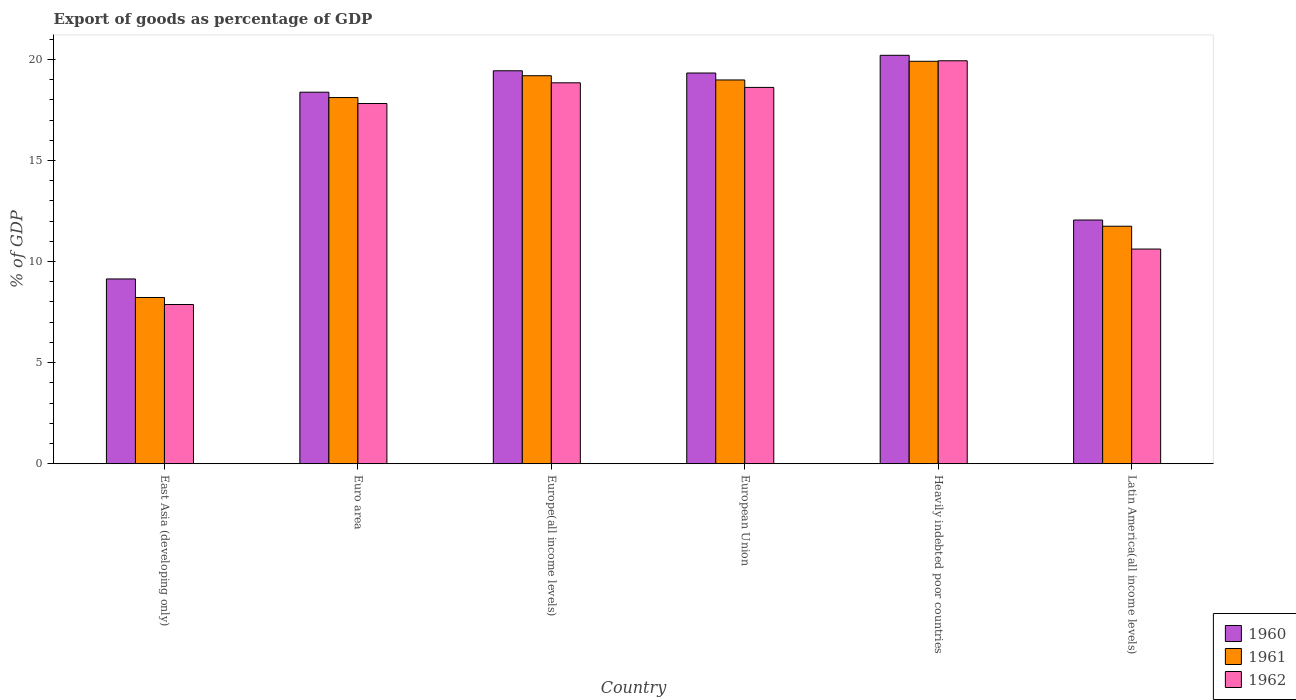How many groups of bars are there?
Give a very brief answer. 6. Are the number of bars on each tick of the X-axis equal?
Make the answer very short. Yes. How many bars are there on the 4th tick from the right?
Offer a terse response. 3. What is the label of the 2nd group of bars from the left?
Your answer should be compact. Euro area. What is the export of goods as percentage of GDP in 1961 in East Asia (developing only)?
Give a very brief answer. 8.22. Across all countries, what is the maximum export of goods as percentage of GDP in 1961?
Keep it short and to the point. 19.9. Across all countries, what is the minimum export of goods as percentage of GDP in 1962?
Give a very brief answer. 7.88. In which country was the export of goods as percentage of GDP in 1960 maximum?
Make the answer very short. Heavily indebted poor countries. In which country was the export of goods as percentage of GDP in 1961 minimum?
Make the answer very short. East Asia (developing only). What is the total export of goods as percentage of GDP in 1962 in the graph?
Your answer should be very brief. 93.7. What is the difference between the export of goods as percentage of GDP in 1961 in Euro area and that in Heavily indebted poor countries?
Your answer should be very brief. -1.79. What is the difference between the export of goods as percentage of GDP in 1961 in European Union and the export of goods as percentage of GDP in 1962 in Europe(all income levels)?
Your response must be concise. 0.14. What is the average export of goods as percentage of GDP in 1961 per country?
Ensure brevity in your answer.  16.03. What is the difference between the export of goods as percentage of GDP of/in 1961 and export of goods as percentage of GDP of/in 1962 in European Union?
Keep it short and to the point. 0.37. In how many countries, is the export of goods as percentage of GDP in 1962 greater than 10 %?
Your answer should be compact. 5. What is the ratio of the export of goods as percentage of GDP in 1961 in Euro area to that in Heavily indebted poor countries?
Keep it short and to the point. 0.91. Is the difference between the export of goods as percentage of GDP in 1961 in Heavily indebted poor countries and Latin America(all income levels) greater than the difference between the export of goods as percentage of GDP in 1962 in Heavily indebted poor countries and Latin America(all income levels)?
Your answer should be compact. No. What is the difference between the highest and the second highest export of goods as percentage of GDP in 1961?
Keep it short and to the point. 0.21. What is the difference between the highest and the lowest export of goods as percentage of GDP in 1962?
Offer a very short reply. 12.06. In how many countries, is the export of goods as percentage of GDP in 1962 greater than the average export of goods as percentage of GDP in 1962 taken over all countries?
Ensure brevity in your answer.  4. What does the 3rd bar from the left in Heavily indebted poor countries represents?
Your answer should be compact. 1962. How many bars are there?
Provide a short and direct response. 18. Are all the bars in the graph horizontal?
Give a very brief answer. No. What is the difference between two consecutive major ticks on the Y-axis?
Give a very brief answer. 5. Are the values on the major ticks of Y-axis written in scientific E-notation?
Offer a very short reply. No. Where does the legend appear in the graph?
Give a very brief answer. Bottom right. How are the legend labels stacked?
Your answer should be compact. Vertical. What is the title of the graph?
Provide a short and direct response. Export of goods as percentage of GDP. What is the label or title of the X-axis?
Offer a terse response. Country. What is the label or title of the Y-axis?
Make the answer very short. % of GDP. What is the % of GDP of 1960 in East Asia (developing only)?
Your answer should be compact. 9.14. What is the % of GDP in 1961 in East Asia (developing only)?
Your response must be concise. 8.22. What is the % of GDP in 1962 in East Asia (developing only)?
Keep it short and to the point. 7.88. What is the % of GDP of 1960 in Euro area?
Offer a terse response. 18.38. What is the % of GDP in 1961 in Euro area?
Your response must be concise. 18.11. What is the % of GDP in 1962 in Euro area?
Keep it short and to the point. 17.82. What is the % of GDP of 1960 in Europe(all income levels)?
Offer a very short reply. 19.44. What is the % of GDP in 1961 in Europe(all income levels)?
Provide a short and direct response. 19.19. What is the % of GDP in 1962 in Europe(all income levels)?
Ensure brevity in your answer.  18.84. What is the % of GDP in 1960 in European Union?
Your answer should be compact. 19.33. What is the % of GDP in 1961 in European Union?
Give a very brief answer. 18.98. What is the % of GDP of 1962 in European Union?
Your response must be concise. 18.61. What is the % of GDP of 1960 in Heavily indebted poor countries?
Give a very brief answer. 20.2. What is the % of GDP in 1961 in Heavily indebted poor countries?
Offer a terse response. 19.9. What is the % of GDP of 1962 in Heavily indebted poor countries?
Ensure brevity in your answer.  19.93. What is the % of GDP of 1960 in Latin America(all income levels)?
Ensure brevity in your answer.  12.05. What is the % of GDP in 1961 in Latin America(all income levels)?
Make the answer very short. 11.75. What is the % of GDP in 1962 in Latin America(all income levels)?
Offer a terse response. 10.62. Across all countries, what is the maximum % of GDP of 1960?
Offer a very short reply. 20.2. Across all countries, what is the maximum % of GDP in 1961?
Provide a succinct answer. 19.9. Across all countries, what is the maximum % of GDP in 1962?
Offer a terse response. 19.93. Across all countries, what is the minimum % of GDP of 1960?
Your answer should be very brief. 9.14. Across all countries, what is the minimum % of GDP of 1961?
Provide a short and direct response. 8.22. Across all countries, what is the minimum % of GDP in 1962?
Your answer should be very brief. 7.88. What is the total % of GDP of 1960 in the graph?
Provide a succinct answer. 98.53. What is the total % of GDP of 1961 in the graph?
Keep it short and to the point. 96.16. What is the total % of GDP in 1962 in the graph?
Ensure brevity in your answer.  93.7. What is the difference between the % of GDP in 1960 in East Asia (developing only) and that in Euro area?
Offer a terse response. -9.24. What is the difference between the % of GDP of 1961 in East Asia (developing only) and that in Euro area?
Your answer should be very brief. -9.89. What is the difference between the % of GDP of 1962 in East Asia (developing only) and that in Euro area?
Provide a succinct answer. -9.94. What is the difference between the % of GDP of 1960 in East Asia (developing only) and that in Europe(all income levels)?
Your answer should be very brief. -10.3. What is the difference between the % of GDP of 1961 in East Asia (developing only) and that in Europe(all income levels)?
Your answer should be compact. -10.97. What is the difference between the % of GDP of 1962 in East Asia (developing only) and that in Europe(all income levels)?
Give a very brief answer. -10.97. What is the difference between the % of GDP in 1960 in East Asia (developing only) and that in European Union?
Offer a terse response. -10.19. What is the difference between the % of GDP in 1961 in East Asia (developing only) and that in European Union?
Your answer should be compact. -10.76. What is the difference between the % of GDP in 1962 in East Asia (developing only) and that in European Union?
Your response must be concise. -10.74. What is the difference between the % of GDP in 1960 in East Asia (developing only) and that in Heavily indebted poor countries?
Your answer should be very brief. -11.06. What is the difference between the % of GDP of 1961 in East Asia (developing only) and that in Heavily indebted poor countries?
Give a very brief answer. -11.68. What is the difference between the % of GDP of 1962 in East Asia (developing only) and that in Heavily indebted poor countries?
Provide a short and direct response. -12.06. What is the difference between the % of GDP in 1960 in East Asia (developing only) and that in Latin America(all income levels)?
Your answer should be compact. -2.91. What is the difference between the % of GDP in 1961 in East Asia (developing only) and that in Latin America(all income levels)?
Offer a terse response. -3.52. What is the difference between the % of GDP in 1962 in East Asia (developing only) and that in Latin America(all income levels)?
Your answer should be very brief. -2.74. What is the difference between the % of GDP in 1960 in Euro area and that in Europe(all income levels)?
Your response must be concise. -1.06. What is the difference between the % of GDP in 1961 in Euro area and that in Europe(all income levels)?
Your answer should be compact. -1.08. What is the difference between the % of GDP in 1962 in Euro area and that in Europe(all income levels)?
Offer a terse response. -1.03. What is the difference between the % of GDP of 1960 in Euro area and that in European Union?
Offer a terse response. -0.95. What is the difference between the % of GDP in 1961 in Euro area and that in European Union?
Your answer should be compact. -0.87. What is the difference between the % of GDP of 1962 in Euro area and that in European Union?
Provide a short and direct response. -0.8. What is the difference between the % of GDP in 1960 in Euro area and that in Heavily indebted poor countries?
Provide a short and direct response. -1.82. What is the difference between the % of GDP in 1961 in Euro area and that in Heavily indebted poor countries?
Give a very brief answer. -1.79. What is the difference between the % of GDP in 1962 in Euro area and that in Heavily indebted poor countries?
Your answer should be compact. -2.11. What is the difference between the % of GDP of 1960 in Euro area and that in Latin America(all income levels)?
Offer a terse response. 6.32. What is the difference between the % of GDP of 1961 in Euro area and that in Latin America(all income levels)?
Your answer should be very brief. 6.36. What is the difference between the % of GDP of 1962 in Euro area and that in Latin America(all income levels)?
Provide a succinct answer. 7.2. What is the difference between the % of GDP of 1960 in Europe(all income levels) and that in European Union?
Give a very brief answer. 0.11. What is the difference between the % of GDP of 1961 in Europe(all income levels) and that in European Union?
Offer a terse response. 0.21. What is the difference between the % of GDP in 1962 in Europe(all income levels) and that in European Union?
Keep it short and to the point. 0.23. What is the difference between the % of GDP in 1960 in Europe(all income levels) and that in Heavily indebted poor countries?
Make the answer very short. -0.77. What is the difference between the % of GDP in 1961 in Europe(all income levels) and that in Heavily indebted poor countries?
Your answer should be very brief. -0.71. What is the difference between the % of GDP of 1962 in Europe(all income levels) and that in Heavily indebted poor countries?
Your answer should be very brief. -1.09. What is the difference between the % of GDP of 1960 in Europe(all income levels) and that in Latin America(all income levels)?
Provide a short and direct response. 7.38. What is the difference between the % of GDP in 1961 in Europe(all income levels) and that in Latin America(all income levels)?
Your answer should be compact. 7.44. What is the difference between the % of GDP in 1962 in Europe(all income levels) and that in Latin America(all income levels)?
Make the answer very short. 8.22. What is the difference between the % of GDP of 1960 in European Union and that in Heavily indebted poor countries?
Provide a succinct answer. -0.88. What is the difference between the % of GDP of 1961 in European Union and that in Heavily indebted poor countries?
Your answer should be very brief. -0.92. What is the difference between the % of GDP in 1962 in European Union and that in Heavily indebted poor countries?
Provide a short and direct response. -1.32. What is the difference between the % of GDP in 1960 in European Union and that in Latin America(all income levels)?
Your response must be concise. 7.27. What is the difference between the % of GDP in 1961 in European Union and that in Latin America(all income levels)?
Your answer should be compact. 7.23. What is the difference between the % of GDP in 1962 in European Union and that in Latin America(all income levels)?
Provide a short and direct response. 7.99. What is the difference between the % of GDP of 1960 in Heavily indebted poor countries and that in Latin America(all income levels)?
Provide a succinct answer. 8.15. What is the difference between the % of GDP in 1961 in Heavily indebted poor countries and that in Latin America(all income levels)?
Give a very brief answer. 8.16. What is the difference between the % of GDP of 1962 in Heavily indebted poor countries and that in Latin America(all income levels)?
Your answer should be compact. 9.31. What is the difference between the % of GDP in 1960 in East Asia (developing only) and the % of GDP in 1961 in Euro area?
Provide a succinct answer. -8.97. What is the difference between the % of GDP of 1960 in East Asia (developing only) and the % of GDP of 1962 in Euro area?
Your answer should be very brief. -8.68. What is the difference between the % of GDP in 1961 in East Asia (developing only) and the % of GDP in 1962 in Euro area?
Your answer should be very brief. -9.59. What is the difference between the % of GDP in 1960 in East Asia (developing only) and the % of GDP in 1961 in Europe(all income levels)?
Your answer should be compact. -10.05. What is the difference between the % of GDP of 1960 in East Asia (developing only) and the % of GDP of 1962 in Europe(all income levels)?
Your answer should be compact. -9.7. What is the difference between the % of GDP of 1961 in East Asia (developing only) and the % of GDP of 1962 in Europe(all income levels)?
Provide a succinct answer. -10.62. What is the difference between the % of GDP of 1960 in East Asia (developing only) and the % of GDP of 1961 in European Union?
Your response must be concise. -9.84. What is the difference between the % of GDP of 1960 in East Asia (developing only) and the % of GDP of 1962 in European Union?
Your response must be concise. -9.47. What is the difference between the % of GDP in 1961 in East Asia (developing only) and the % of GDP in 1962 in European Union?
Provide a succinct answer. -10.39. What is the difference between the % of GDP in 1960 in East Asia (developing only) and the % of GDP in 1961 in Heavily indebted poor countries?
Keep it short and to the point. -10.77. What is the difference between the % of GDP of 1960 in East Asia (developing only) and the % of GDP of 1962 in Heavily indebted poor countries?
Offer a very short reply. -10.79. What is the difference between the % of GDP of 1961 in East Asia (developing only) and the % of GDP of 1962 in Heavily indebted poor countries?
Give a very brief answer. -11.71. What is the difference between the % of GDP in 1960 in East Asia (developing only) and the % of GDP in 1961 in Latin America(all income levels)?
Offer a terse response. -2.61. What is the difference between the % of GDP of 1960 in East Asia (developing only) and the % of GDP of 1962 in Latin America(all income levels)?
Provide a short and direct response. -1.48. What is the difference between the % of GDP in 1961 in East Asia (developing only) and the % of GDP in 1962 in Latin America(all income levels)?
Provide a short and direct response. -2.4. What is the difference between the % of GDP of 1960 in Euro area and the % of GDP of 1961 in Europe(all income levels)?
Your answer should be very brief. -0.81. What is the difference between the % of GDP of 1960 in Euro area and the % of GDP of 1962 in Europe(all income levels)?
Keep it short and to the point. -0.46. What is the difference between the % of GDP of 1961 in Euro area and the % of GDP of 1962 in Europe(all income levels)?
Give a very brief answer. -0.73. What is the difference between the % of GDP of 1960 in Euro area and the % of GDP of 1961 in European Union?
Your answer should be very brief. -0.61. What is the difference between the % of GDP in 1960 in Euro area and the % of GDP in 1962 in European Union?
Make the answer very short. -0.24. What is the difference between the % of GDP of 1961 in Euro area and the % of GDP of 1962 in European Union?
Your response must be concise. -0.5. What is the difference between the % of GDP of 1960 in Euro area and the % of GDP of 1961 in Heavily indebted poor countries?
Your answer should be very brief. -1.53. What is the difference between the % of GDP in 1960 in Euro area and the % of GDP in 1962 in Heavily indebted poor countries?
Your response must be concise. -1.55. What is the difference between the % of GDP in 1961 in Euro area and the % of GDP in 1962 in Heavily indebted poor countries?
Give a very brief answer. -1.82. What is the difference between the % of GDP of 1960 in Euro area and the % of GDP of 1961 in Latin America(all income levels)?
Give a very brief answer. 6.63. What is the difference between the % of GDP in 1960 in Euro area and the % of GDP in 1962 in Latin America(all income levels)?
Your response must be concise. 7.76. What is the difference between the % of GDP of 1961 in Euro area and the % of GDP of 1962 in Latin America(all income levels)?
Give a very brief answer. 7.49. What is the difference between the % of GDP of 1960 in Europe(all income levels) and the % of GDP of 1961 in European Union?
Your answer should be compact. 0.45. What is the difference between the % of GDP of 1960 in Europe(all income levels) and the % of GDP of 1962 in European Union?
Keep it short and to the point. 0.82. What is the difference between the % of GDP of 1961 in Europe(all income levels) and the % of GDP of 1962 in European Union?
Provide a succinct answer. 0.58. What is the difference between the % of GDP of 1960 in Europe(all income levels) and the % of GDP of 1961 in Heavily indebted poor countries?
Offer a very short reply. -0.47. What is the difference between the % of GDP of 1960 in Europe(all income levels) and the % of GDP of 1962 in Heavily indebted poor countries?
Give a very brief answer. -0.49. What is the difference between the % of GDP in 1961 in Europe(all income levels) and the % of GDP in 1962 in Heavily indebted poor countries?
Your answer should be compact. -0.74. What is the difference between the % of GDP in 1960 in Europe(all income levels) and the % of GDP in 1961 in Latin America(all income levels)?
Provide a succinct answer. 7.69. What is the difference between the % of GDP in 1960 in Europe(all income levels) and the % of GDP in 1962 in Latin America(all income levels)?
Offer a very short reply. 8.82. What is the difference between the % of GDP in 1961 in Europe(all income levels) and the % of GDP in 1962 in Latin America(all income levels)?
Ensure brevity in your answer.  8.57. What is the difference between the % of GDP in 1960 in European Union and the % of GDP in 1961 in Heavily indebted poor countries?
Offer a very short reply. -0.58. What is the difference between the % of GDP in 1960 in European Union and the % of GDP in 1962 in Heavily indebted poor countries?
Your answer should be very brief. -0.61. What is the difference between the % of GDP of 1961 in European Union and the % of GDP of 1962 in Heavily indebted poor countries?
Your response must be concise. -0.95. What is the difference between the % of GDP of 1960 in European Union and the % of GDP of 1961 in Latin America(all income levels)?
Make the answer very short. 7.58. What is the difference between the % of GDP in 1960 in European Union and the % of GDP in 1962 in Latin America(all income levels)?
Give a very brief answer. 8.71. What is the difference between the % of GDP in 1961 in European Union and the % of GDP in 1962 in Latin America(all income levels)?
Make the answer very short. 8.36. What is the difference between the % of GDP of 1960 in Heavily indebted poor countries and the % of GDP of 1961 in Latin America(all income levels)?
Offer a very short reply. 8.45. What is the difference between the % of GDP in 1960 in Heavily indebted poor countries and the % of GDP in 1962 in Latin America(all income levels)?
Give a very brief answer. 9.58. What is the difference between the % of GDP of 1961 in Heavily indebted poor countries and the % of GDP of 1962 in Latin America(all income levels)?
Keep it short and to the point. 9.29. What is the average % of GDP in 1960 per country?
Offer a very short reply. 16.42. What is the average % of GDP of 1961 per country?
Ensure brevity in your answer.  16.03. What is the average % of GDP in 1962 per country?
Offer a very short reply. 15.62. What is the difference between the % of GDP in 1960 and % of GDP in 1961 in East Asia (developing only)?
Keep it short and to the point. 0.92. What is the difference between the % of GDP of 1960 and % of GDP of 1962 in East Asia (developing only)?
Make the answer very short. 1.26. What is the difference between the % of GDP in 1961 and % of GDP in 1962 in East Asia (developing only)?
Your answer should be very brief. 0.35. What is the difference between the % of GDP of 1960 and % of GDP of 1961 in Euro area?
Offer a very short reply. 0.27. What is the difference between the % of GDP of 1960 and % of GDP of 1962 in Euro area?
Offer a terse response. 0.56. What is the difference between the % of GDP in 1961 and % of GDP in 1962 in Euro area?
Offer a terse response. 0.3. What is the difference between the % of GDP in 1960 and % of GDP in 1961 in Europe(all income levels)?
Your answer should be very brief. 0.24. What is the difference between the % of GDP in 1960 and % of GDP in 1962 in Europe(all income levels)?
Provide a succinct answer. 0.59. What is the difference between the % of GDP in 1961 and % of GDP in 1962 in Europe(all income levels)?
Your answer should be very brief. 0.35. What is the difference between the % of GDP in 1960 and % of GDP in 1961 in European Union?
Make the answer very short. 0.34. What is the difference between the % of GDP in 1960 and % of GDP in 1962 in European Union?
Your response must be concise. 0.71. What is the difference between the % of GDP in 1961 and % of GDP in 1962 in European Union?
Provide a succinct answer. 0.37. What is the difference between the % of GDP of 1960 and % of GDP of 1961 in Heavily indebted poor countries?
Make the answer very short. 0.3. What is the difference between the % of GDP of 1960 and % of GDP of 1962 in Heavily indebted poor countries?
Give a very brief answer. 0.27. What is the difference between the % of GDP of 1961 and % of GDP of 1962 in Heavily indebted poor countries?
Ensure brevity in your answer.  -0.03. What is the difference between the % of GDP in 1960 and % of GDP in 1961 in Latin America(all income levels)?
Keep it short and to the point. 0.31. What is the difference between the % of GDP of 1960 and % of GDP of 1962 in Latin America(all income levels)?
Provide a succinct answer. 1.44. What is the difference between the % of GDP in 1961 and % of GDP in 1962 in Latin America(all income levels)?
Ensure brevity in your answer.  1.13. What is the ratio of the % of GDP in 1960 in East Asia (developing only) to that in Euro area?
Offer a terse response. 0.5. What is the ratio of the % of GDP in 1961 in East Asia (developing only) to that in Euro area?
Your answer should be very brief. 0.45. What is the ratio of the % of GDP in 1962 in East Asia (developing only) to that in Euro area?
Provide a succinct answer. 0.44. What is the ratio of the % of GDP in 1960 in East Asia (developing only) to that in Europe(all income levels)?
Your answer should be very brief. 0.47. What is the ratio of the % of GDP of 1961 in East Asia (developing only) to that in Europe(all income levels)?
Your response must be concise. 0.43. What is the ratio of the % of GDP of 1962 in East Asia (developing only) to that in Europe(all income levels)?
Provide a short and direct response. 0.42. What is the ratio of the % of GDP of 1960 in East Asia (developing only) to that in European Union?
Provide a succinct answer. 0.47. What is the ratio of the % of GDP of 1961 in East Asia (developing only) to that in European Union?
Your answer should be compact. 0.43. What is the ratio of the % of GDP of 1962 in East Asia (developing only) to that in European Union?
Keep it short and to the point. 0.42. What is the ratio of the % of GDP of 1960 in East Asia (developing only) to that in Heavily indebted poor countries?
Your response must be concise. 0.45. What is the ratio of the % of GDP of 1961 in East Asia (developing only) to that in Heavily indebted poor countries?
Give a very brief answer. 0.41. What is the ratio of the % of GDP of 1962 in East Asia (developing only) to that in Heavily indebted poor countries?
Provide a short and direct response. 0.4. What is the ratio of the % of GDP in 1960 in East Asia (developing only) to that in Latin America(all income levels)?
Offer a terse response. 0.76. What is the ratio of the % of GDP of 1962 in East Asia (developing only) to that in Latin America(all income levels)?
Make the answer very short. 0.74. What is the ratio of the % of GDP in 1960 in Euro area to that in Europe(all income levels)?
Offer a terse response. 0.95. What is the ratio of the % of GDP in 1961 in Euro area to that in Europe(all income levels)?
Keep it short and to the point. 0.94. What is the ratio of the % of GDP of 1962 in Euro area to that in Europe(all income levels)?
Your answer should be compact. 0.95. What is the ratio of the % of GDP in 1960 in Euro area to that in European Union?
Your answer should be very brief. 0.95. What is the ratio of the % of GDP of 1961 in Euro area to that in European Union?
Offer a terse response. 0.95. What is the ratio of the % of GDP of 1962 in Euro area to that in European Union?
Provide a succinct answer. 0.96. What is the ratio of the % of GDP in 1960 in Euro area to that in Heavily indebted poor countries?
Your response must be concise. 0.91. What is the ratio of the % of GDP of 1961 in Euro area to that in Heavily indebted poor countries?
Make the answer very short. 0.91. What is the ratio of the % of GDP in 1962 in Euro area to that in Heavily indebted poor countries?
Your answer should be compact. 0.89. What is the ratio of the % of GDP in 1960 in Euro area to that in Latin America(all income levels)?
Give a very brief answer. 1.52. What is the ratio of the % of GDP of 1961 in Euro area to that in Latin America(all income levels)?
Provide a succinct answer. 1.54. What is the ratio of the % of GDP of 1962 in Euro area to that in Latin America(all income levels)?
Offer a very short reply. 1.68. What is the ratio of the % of GDP in 1962 in Europe(all income levels) to that in European Union?
Provide a succinct answer. 1.01. What is the ratio of the % of GDP of 1960 in Europe(all income levels) to that in Heavily indebted poor countries?
Provide a succinct answer. 0.96. What is the ratio of the % of GDP of 1961 in Europe(all income levels) to that in Heavily indebted poor countries?
Give a very brief answer. 0.96. What is the ratio of the % of GDP in 1962 in Europe(all income levels) to that in Heavily indebted poor countries?
Provide a short and direct response. 0.95. What is the ratio of the % of GDP of 1960 in Europe(all income levels) to that in Latin America(all income levels)?
Ensure brevity in your answer.  1.61. What is the ratio of the % of GDP of 1961 in Europe(all income levels) to that in Latin America(all income levels)?
Keep it short and to the point. 1.63. What is the ratio of the % of GDP of 1962 in Europe(all income levels) to that in Latin America(all income levels)?
Your response must be concise. 1.77. What is the ratio of the % of GDP in 1960 in European Union to that in Heavily indebted poor countries?
Offer a very short reply. 0.96. What is the ratio of the % of GDP of 1961 in European Union to that in Heavily indebted poor countries?
Give a very brief answer. 0.95. What is the ratio of the % of GDP in 1962 in European Union to that in Heavily indebted poor countries?
Make the answer very short. 0.93. What is the ratio of the % of GDP of 1960 in European Union to that in Latin America(all income levels)?
Your answer should be compact. 1.6. What is the ratio of the % of GDP in 1961 in European Union to that in Latin America(all income levels)?
Provide a short and direct response. 1.62. What is the ratio of the % of GDP of 1962 in European Union to that in Latin America(all income levels)?
Keep it short and to the point. 1.75. What is the ratio of the % of GDP in 1960 in Heavily indebted poor countries to that in Latin America(all income levels)?
Provide a succinct answer. 1.68. What is the ratio of the % of GDP in 1961 in Heavily indebted poor countries to that in Latin America(all income levels)?
Make the answer very short. 1.69. What is the ratio of the % of GDP of 1962 in Heavily indebted poor countries to that in Latin America(all income levels)?
Make the answer very short. 1.88. What is the difference between the highest and the second highest % of GDP in 1960?
Offer a very short reply. 0.77. What is the difference between the highest and the second highest % of GDP of 1961?
Give a very brief answer. 0.71. What is the difference between the highest and the second highest % of GDP of 1962?
Keep it short and to the point. 1.09. What is the difference between the highest and the lowest % of GDP in 1960?
Your response must be concise. 11.06. What is the difference between the highest and the lowest % of GDP in 1961?
Your answer should be compact. 11.68. What is the difference between the highest and the lowest % of GDP in 1962?
Provide a succinct answer. 12.06. 